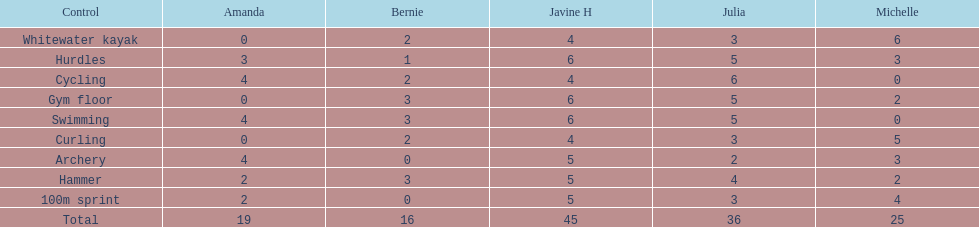Name a girl that had the same score in cycling and archery. Amanda. 